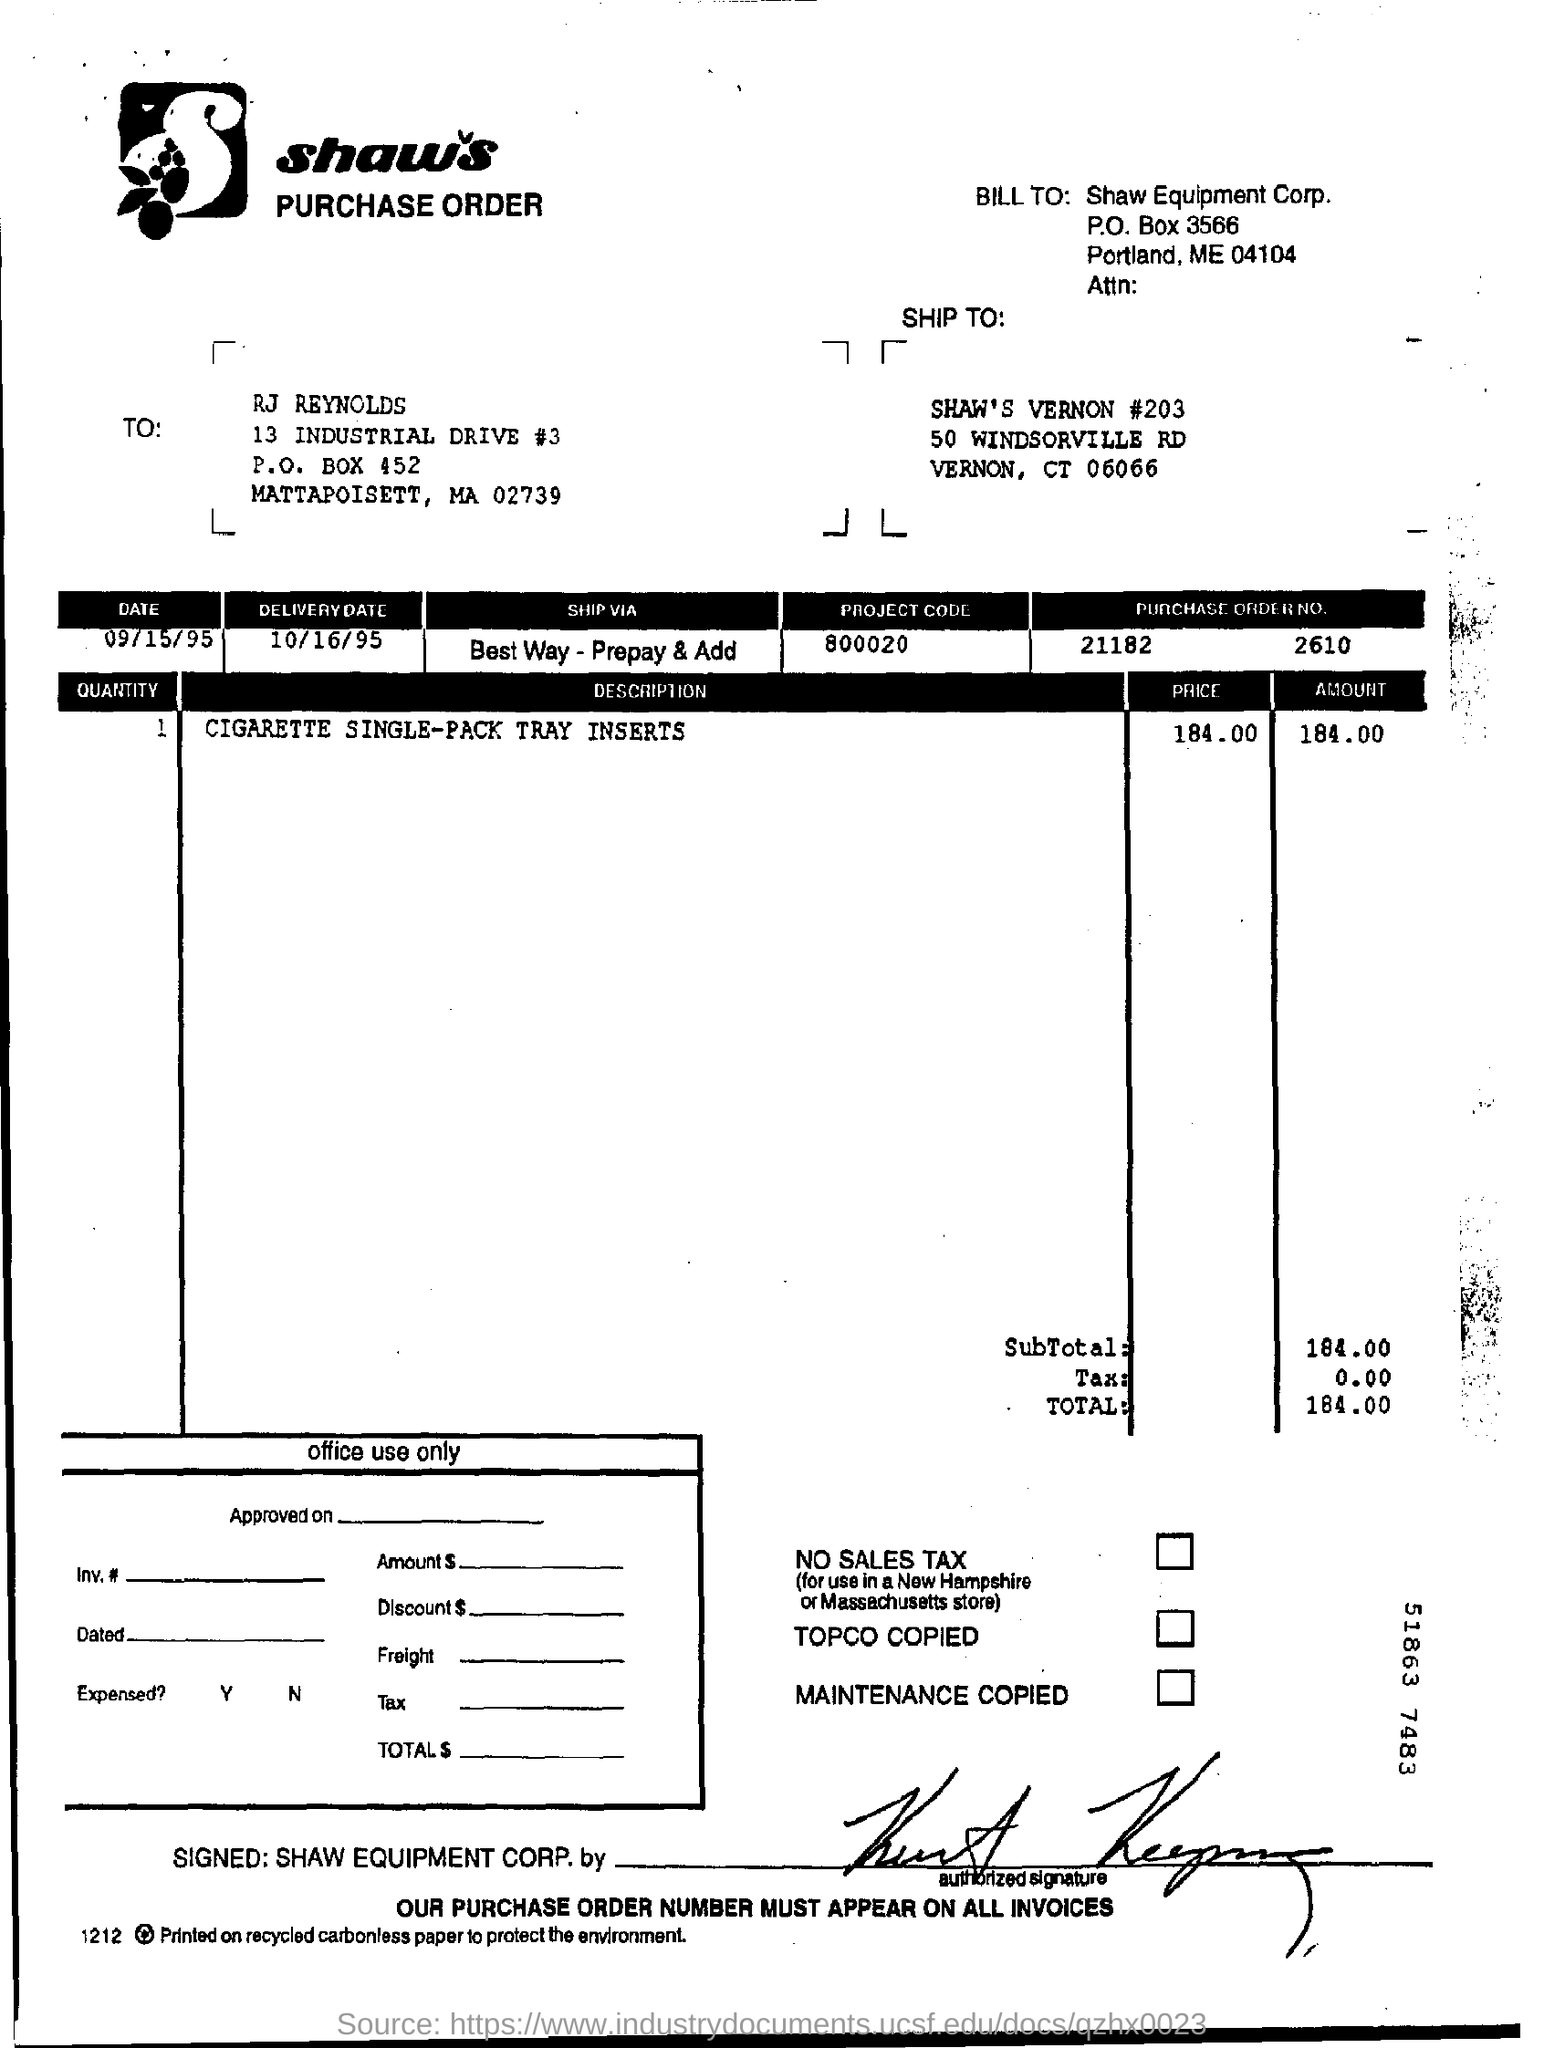What is the delivery date mentioned in the purchase order?
Offer a terse response. 10/16/95. What is the Purchase Order no. given in the document?
Your response must be concise. 21182      2610. What is the project code given in the purchase order?
Offer a terse response. 800020. What is the total amount given in the purchase order?
Your response must be concise. 184.00. What is the description of the quantity mentioned in the purchase order?
Keep it short and to the point. Cigarette single-pack tray inserts. 